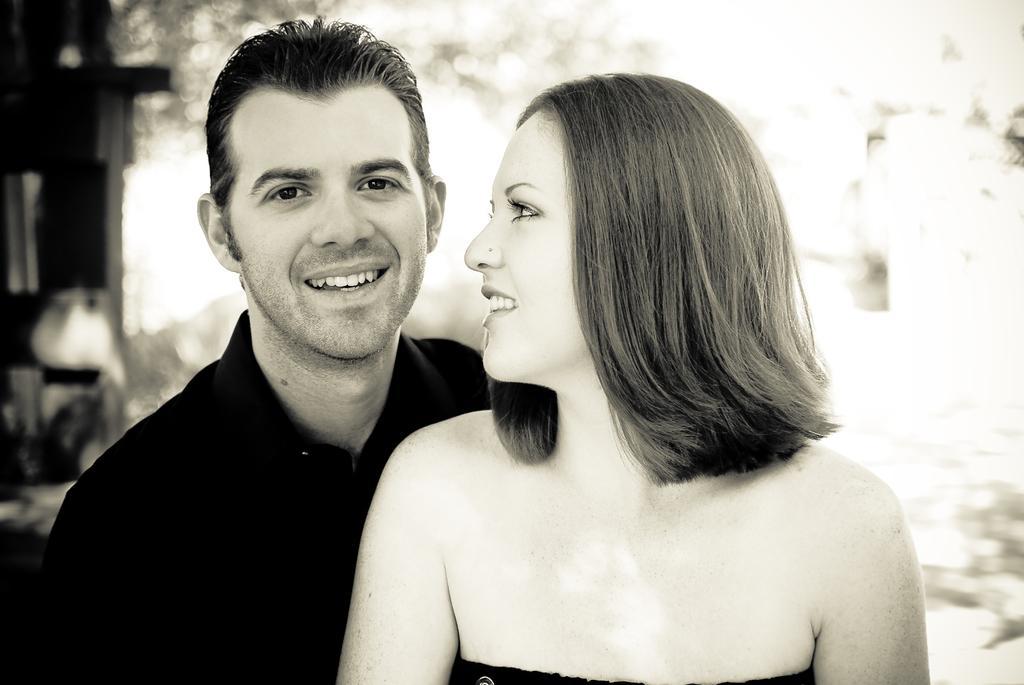Please provide a concise description of this image. In this picture we can see a man and a woman smiling. We can see a few objects in the background. Background is blurry. 